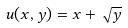<formula> <loc_0><loc_0><loc_500><loc_500>u ( x , y ) = x + \sqrt { y }</formula> 